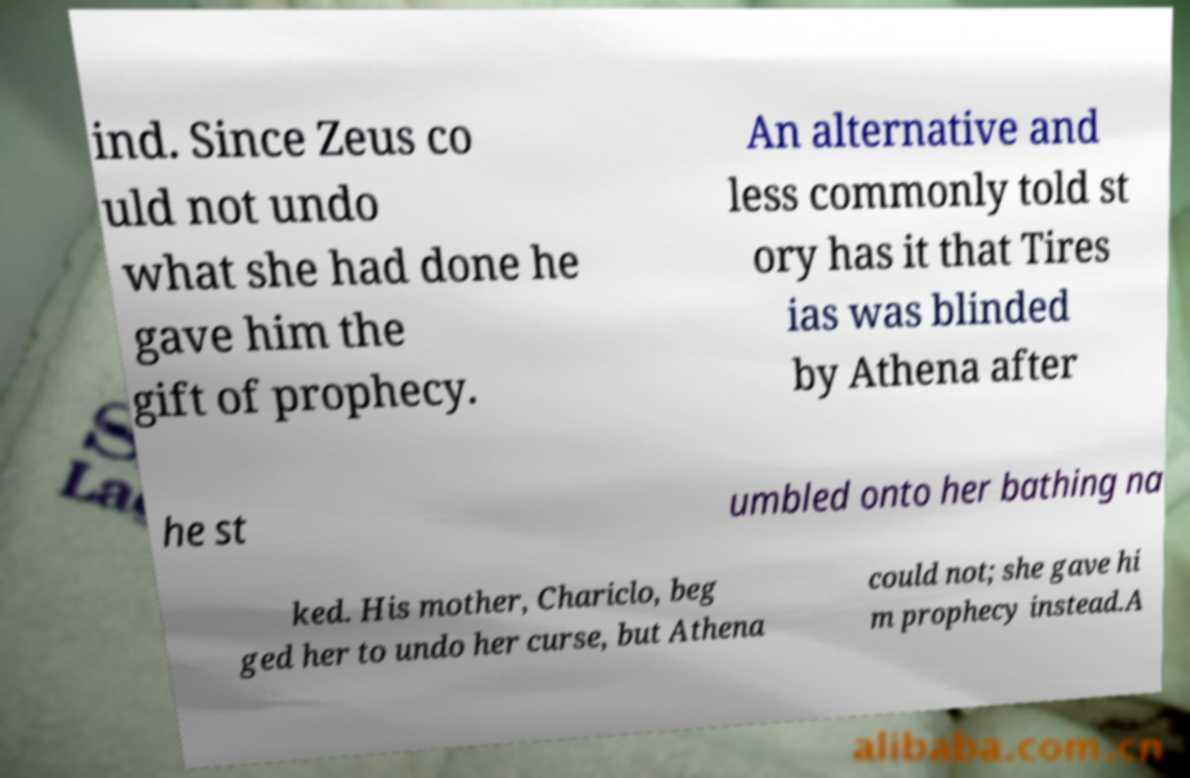Can you accurately transcribe the text from the provided image for me? ind. Since Zeus co uld not undo what she had done he gave him the gift of prophecy. An alternative and less commonly told st ory has it that Tires ias was blinded by Athena after he st umbled onto her bathing na ked. His mother, Chariclo, beg ged her to undo her curse, but Athena could not; she gave hi m prophecy instead.A 